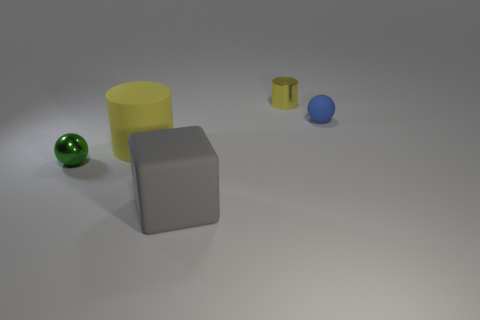Add 1 green shiny spheres. How many objects exist? 6 Subtract 1 cylinders. How many cylinders are left? 1 Add 5 big gray objects. How many big gray objects are left? 6 Add 5 tiny red cylinders. How many tiny red cylinders exist? 5 Subtract 0 cyan cylinders. How many objects are left? 5 Subtract all balls. How many objects are left? 3 Subtract all cyan balls. Subtract all green cylinders. How many balls are left? 2 Subtract all red cylinders. How many green balls are left? 1 Subtract all tiny blue balls. Subtract all big cylinders. How many objects are left? 3 